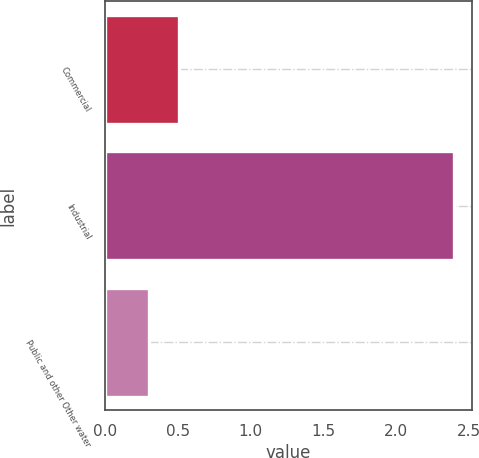<chart> <loc_0><loc_0><loc_500><loc_500><bar_chart><fcel>Commercial<fcel>Industrial<fcel>Public and other Other water<nl><fcel>0.51<fcel>2.4<fcel>0.3<nl></chart> 